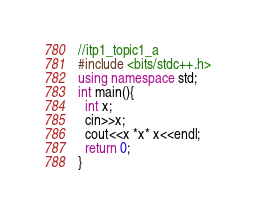<code> <loc_0><loc_0><loc_500><loc_500><_C++_>//itp1_topic1_a
#include <bits/stdc++.h>
using namespace std;
int main(){
  int x;
  cin>>x;
  cout<<x *x* x<<endl;
  return 0;
}
</code> 